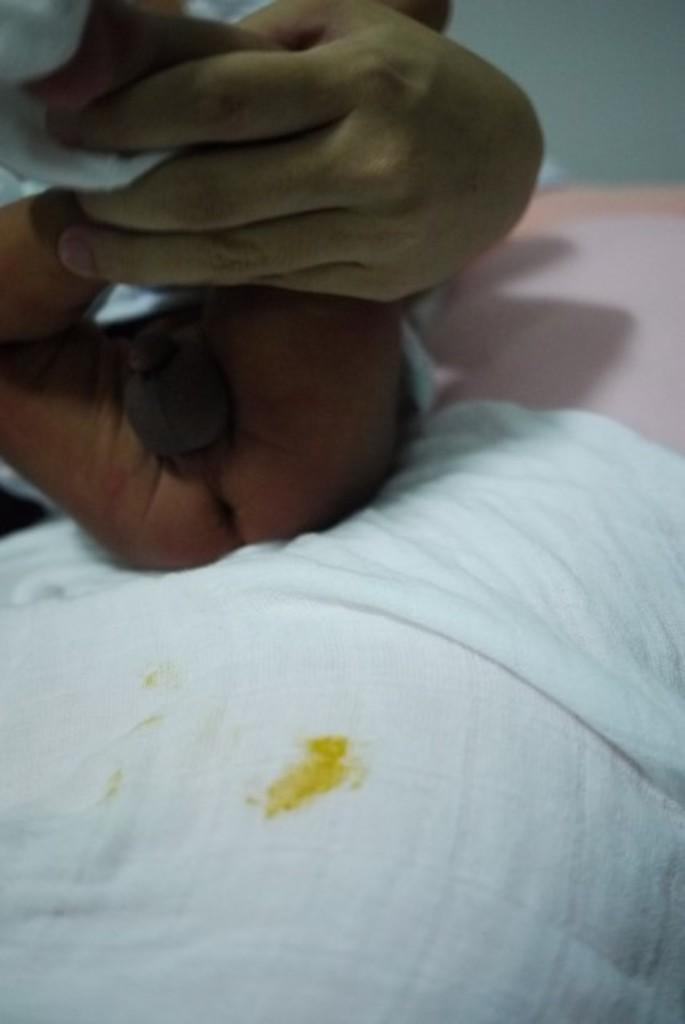What is the person in the image doing with the baby's legs? The person is holding the baby's legs. What is placed underneath the baby in the image? There is a white cloth underneath the baby. Is the baby stuck in quicksand in the image? No, there is no quicksand present in the image. What type of kettle can be seen in the image? There is no kettle present in the image. 